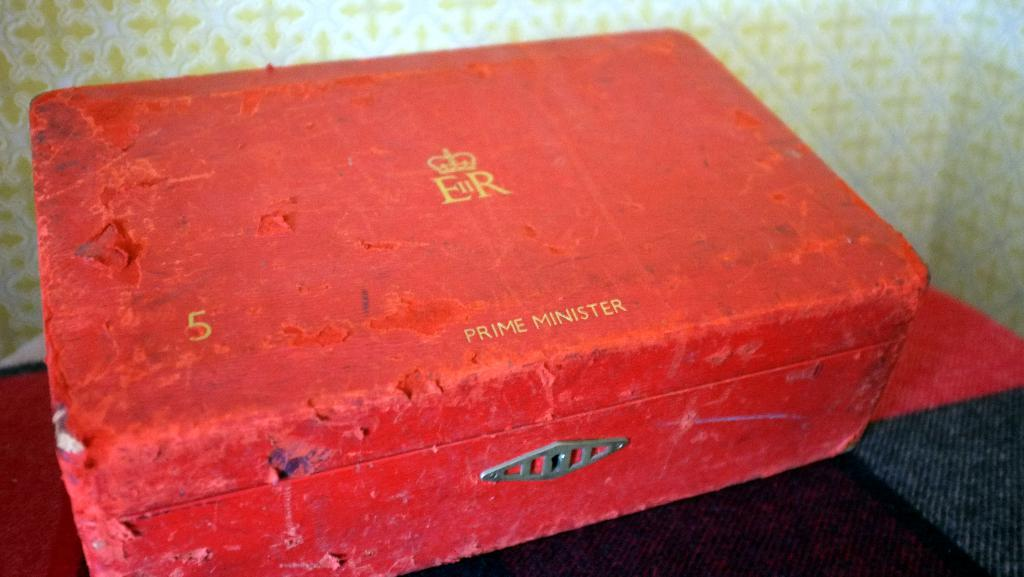What is the color of the box in the image? The box in the image is red. What information is present on the box? There is text and a logo on the box. What can be seen in the background of the image? There is a wall in the background of the image. What is located at the bottom of the image? There is a table at the bottom of the image. What time of day is it in the image? The time of day cannot be determined from the image, as there are no clues or indicators of the time. 